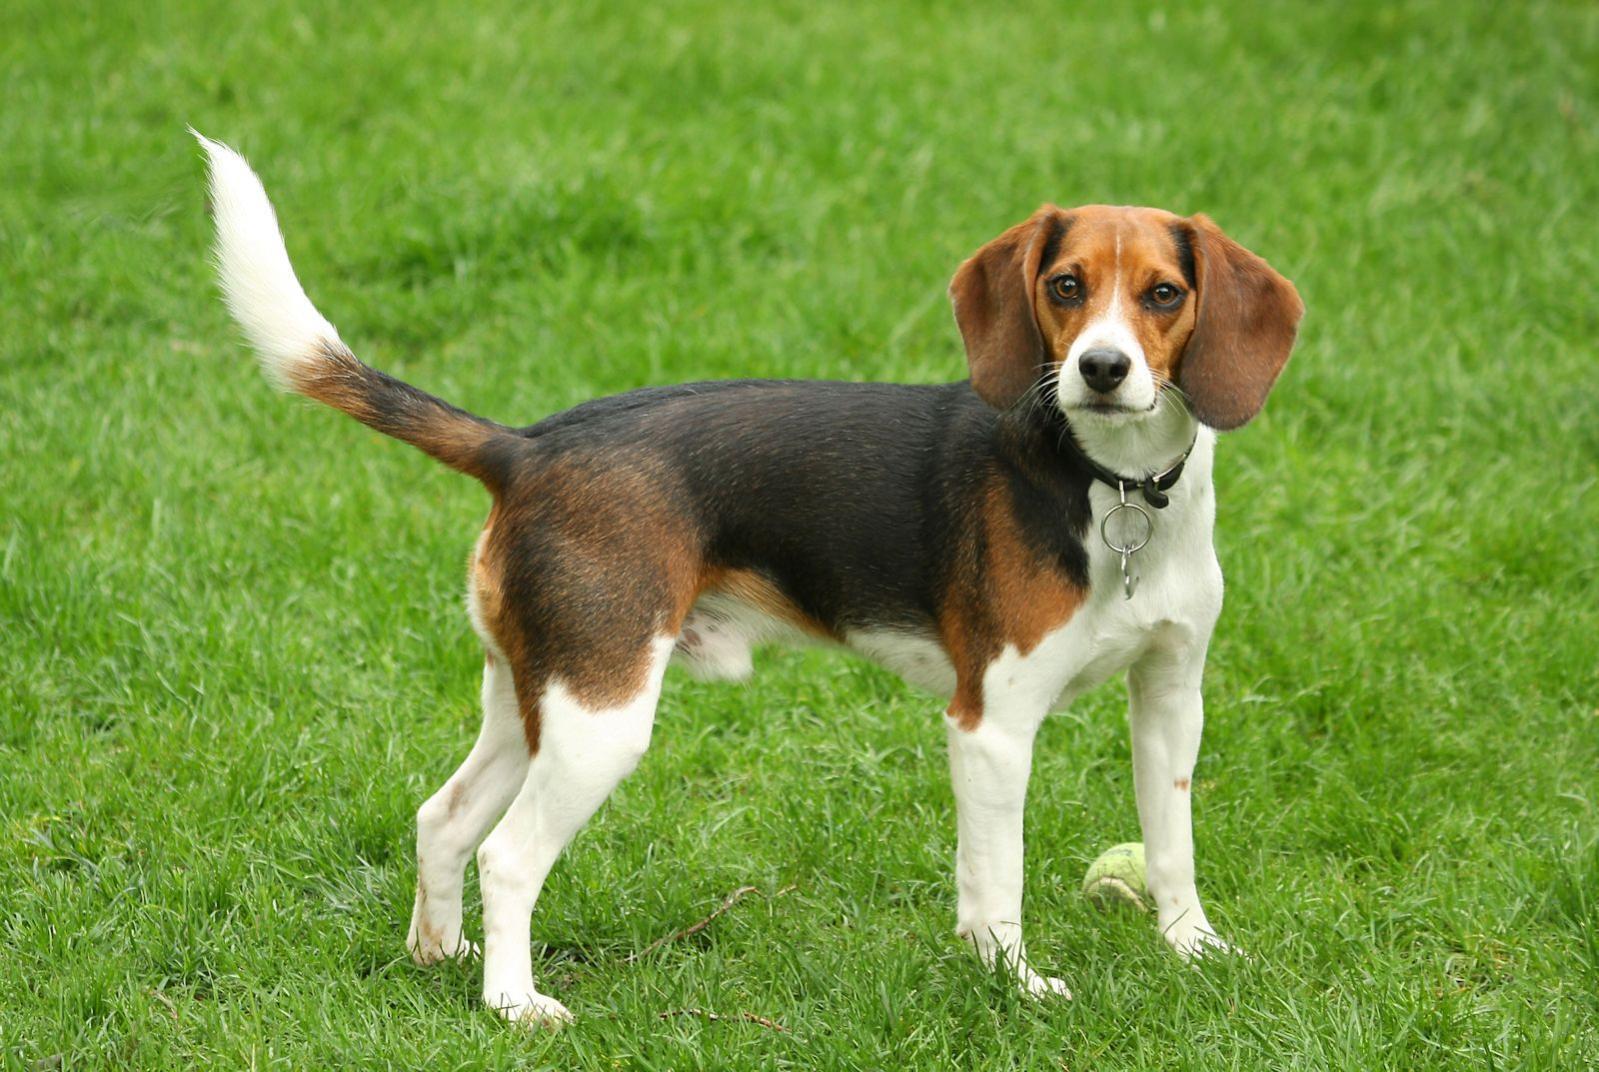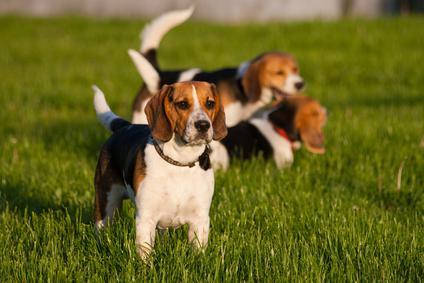The first image is the image on the left, the second image is the image on the right. Given the left and right images, does the statement "There are no more than two animals" hold true? Answer yes or no. No. 